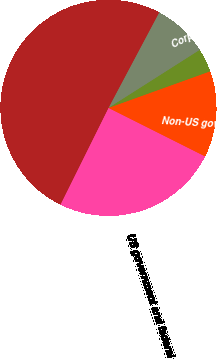Convert chart to OTSL. <chart><loc_0><loc_0><loc_500><loc_500><pie_chart><fcel>US government and federal<fcel>Non-US government and agency<fcel>Corporate debt securities<fcel>Equities and convertible<fcel>Total<nl><fcel>24.93%<fcel>12.9%<fcel>3.52%<fcel>8.21%<fcel>50.43%<nl></chart> 